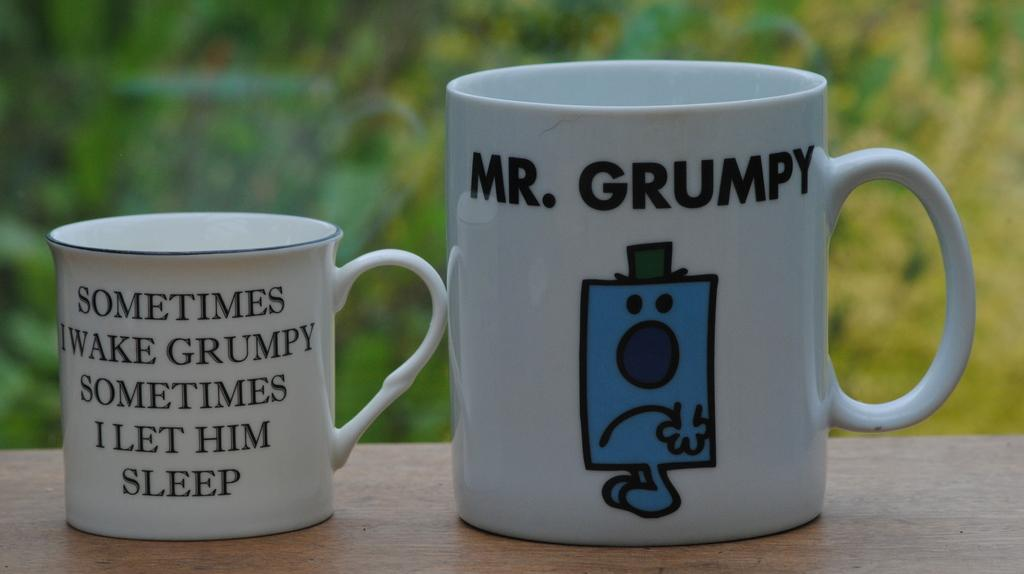Provide a one-sentence caption for the provided image. Two coffee cups feature comical messages about a grumpy person. 